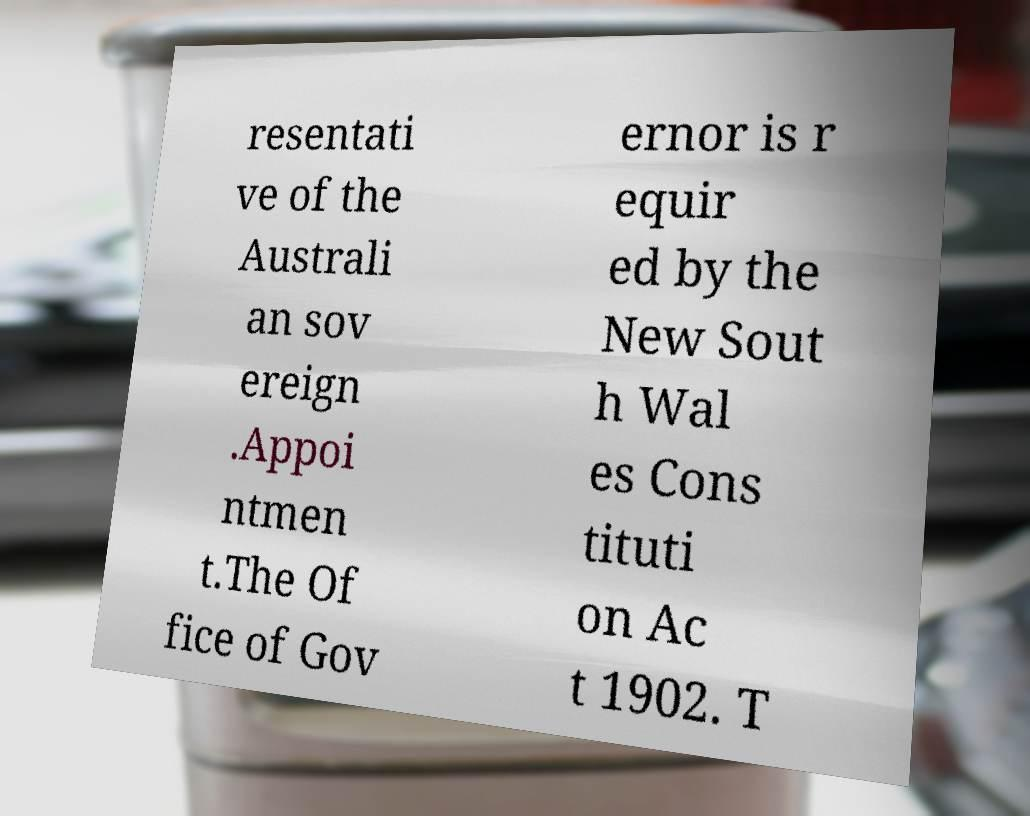I need the written content from this picture converted into text. Can you do that? resentati ve of the Australi an sov ereign .Appoi ntmen t.The Of fice of Gov ernor is r equir ed by the New Sout h Wal es Cons tituti on Ac t 1902. T 